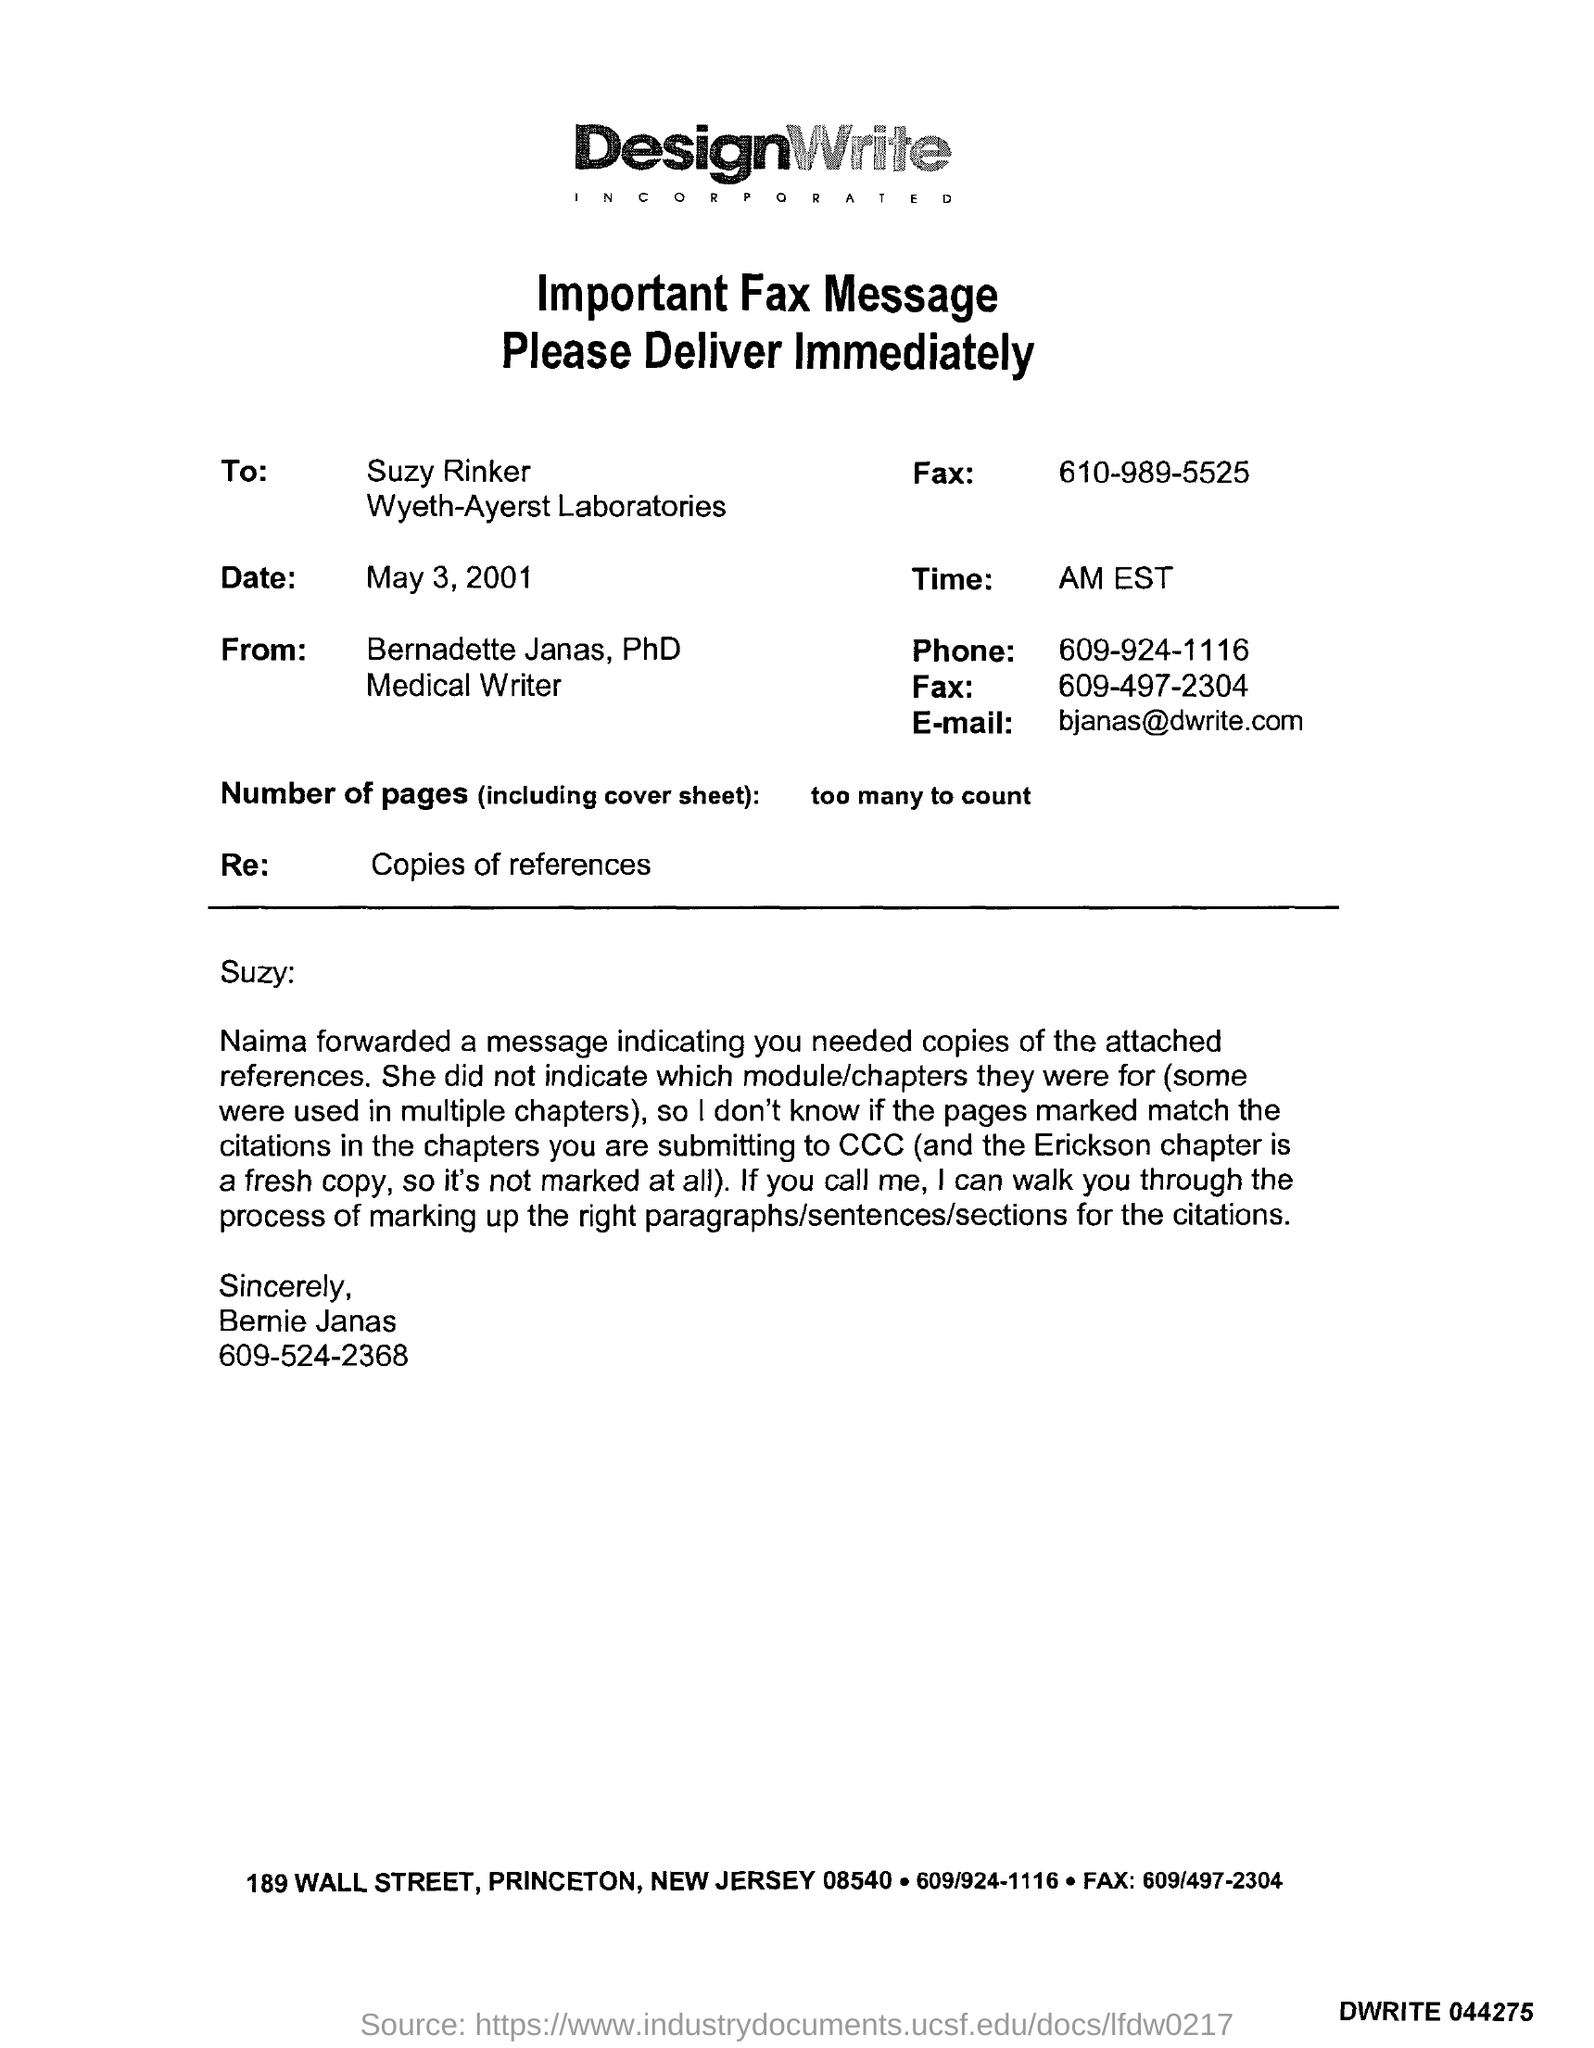What is the name of laboratories ?
Give a very brief answer. Wyeth-Ayerst  Laboratories. How many number of pages were sent including cover page?
Offer a very short reply. Too many to count. When was this fax sent to suzy rinker ?
Your response must be concise. May 3, 2001. 